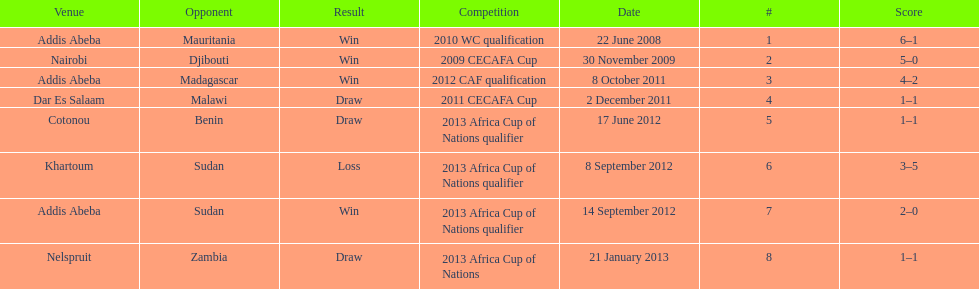For each winning game, what was their score? 6-1, 5-0, 4-2, 2-0. 